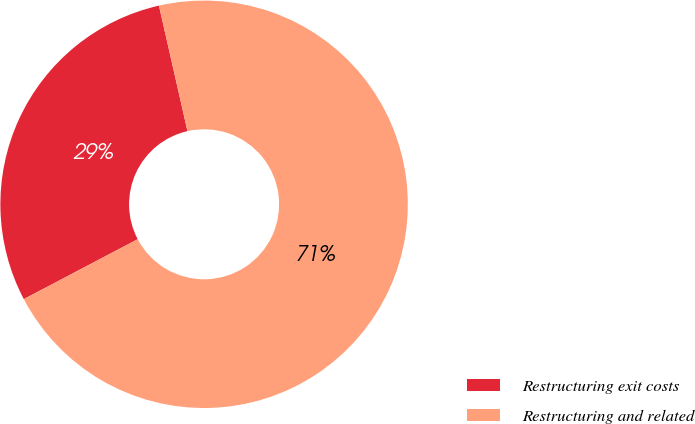<chart> <loc_0><loc_0><loc_500><loc_500><pie_chart><fcel>Restructuring exit costs<fcel>Restructuring and related<nl><fcel>29.15%<fcel>70.85%<nl></chart> 